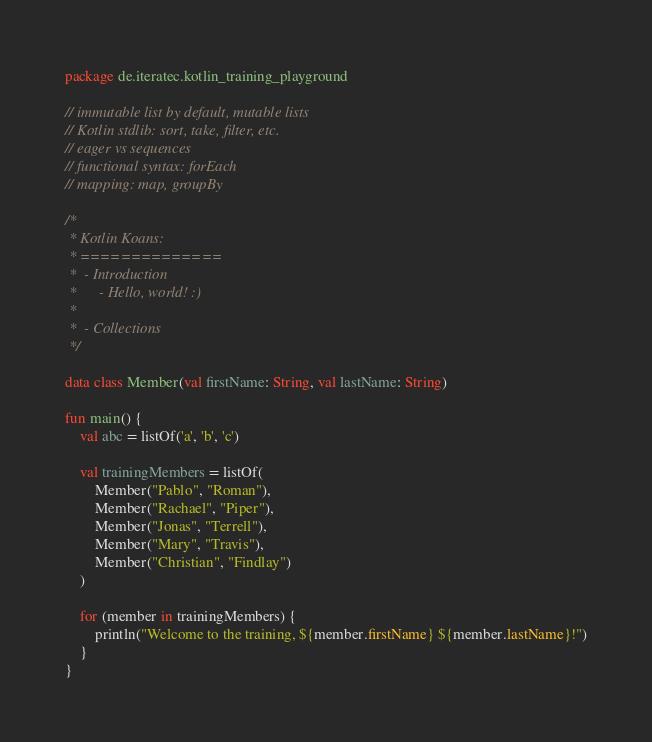<code> <loc_0><loc_0><loc_500><loc_500><_Kotlin_>package de.iteratec.kotlin_training_playground

// immutable list by default, mutable lists
// Kotlin stdlib: sort, take, filter, etc.
// eager vs sequences
// functional syntax: forEach
// mapping: map, groupBy

/*
 * Kotlin Koans:
 * ==============
 *  - Introduction
 *      - Hello, world! :)
 *
 *  - Collections
 */

data class Member(val firstName: String, val lastName: String)

fun main() {
    val abc = listOf('a', 'b', 'c')

    val trainingMembers = listOf(
        Member("Pablo", "Roman"),
        Member("Rachael", "Piper"),
        Member("Jonas", "Terrell"),
        Member("Mary", "Travis"),
        Member("Christian", "Findlay")
    )

    for (member in trainingMembers) {
        println("Welcome to the training, ${member.firstName} ${member.lastName}!")
    }
}


</code> 